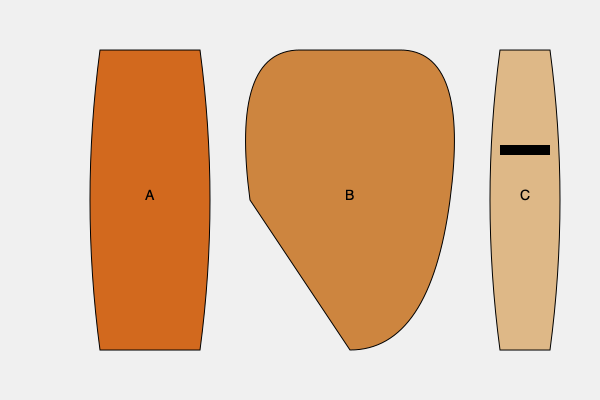Identify the type of ancient Greek pottery labeled 'B' and state which mythological scene it was most commonly used to depict. 1. The image shows three types of ancient Greek pottery.

2. Vessel A is an amphora, characterized by its tall, slender shape with two handles.

3. Vessel B is a krater, identified by its wide bowl shape with a broad mouth and two handles.

4. Vessel C is a hydria, recognizable by its egg-shaped body and distinctive third handle on the back for pouring.

5. The krater (B) was primarily used for mixing wine and water during symposia (drinking parties).

6. Due to its association with symposia, kraters often depicted scenes related to Dionysus, the god of wine and revelry.

7. Common mythological scenes on kraters included:
   - Dionysus and his retinue of satyrs and maenads
   - The return of Hephaestus to Olympus
   - Various myths associated with wine and festivities

8. Among these, the most frequently depicted scene on kraters was Dionysus and his followers, emphasizing the vessel's connection to wine and celebration.
Answer: Krater; Dionysus and his retinue 